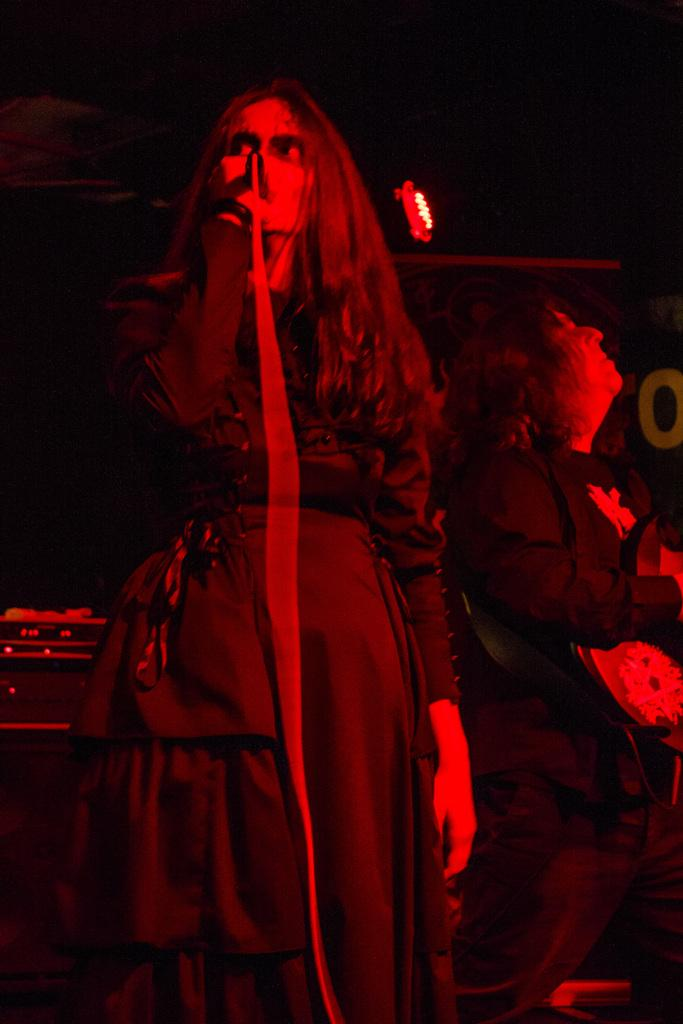How many people are in the image? There are two people in the image. What are the people wearing? Both people are wearing dresses. What is one person doing in the image? One person is holding a microphone. What can be seen in the background of the image? There is lighting visible in the background, and the background is black. What type of bucket is being used to help the person with the microphone in the image? There is no bucket present in the image, and no one is being helped with a bucket. 